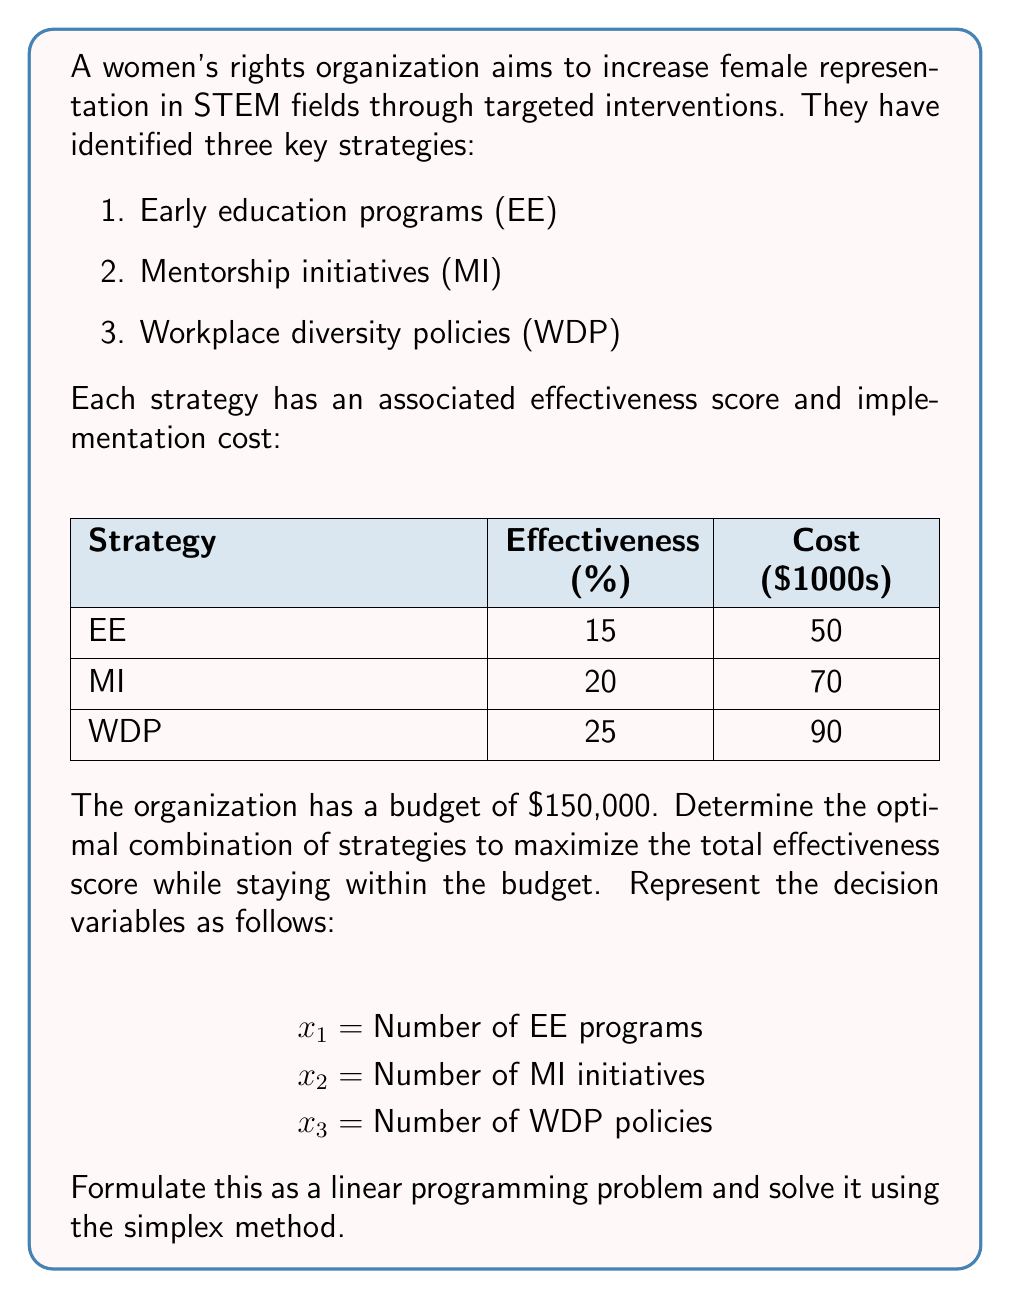Help me with this question. To solve this linear programming problem, we'll follow these steps:

1. Formulate the objective function and constraints
2. Set up the initial simplex tableau
3. Perform iterations until we reach the optimal solution

Step 1: Formulation

Objective function (maximize):
$$Z = 15x_1 + 20x_2 + 25x_3$$

Constraints:
$$50x_1 + 70x_2 + 90x_3 \leq 150$$ (Budget constraint)
$$x_1, x_2, x_3 \geq 0$$ (Non-negativity constraints)

Step 2: Initial Simplex Tableau

Introduce slack variable $s_1$ for the budget constraint:

$$50x_1 + 70x_2 + 90x_3 + s_1 = 150$$

Initial tableau:

| Basic | $x_1$ | $x_2$ | $x_3$ | $s_1$ | RHS |
|-------|-------|-------|-------|-------|-----|
| $s_1$ | 50    | 70    | 90    | 1     | 150 |
| $Z$   | -15   | -20   | -25   | 0     | 0   |

Step 3: Iterations

Iteration 1:
Pivot column: $x_3$ (most negative in $Z$ row)
Pivot row: $s_1$ (only positive ratio)
Pivot element: 90

New tableau:

| Basic | $x_1$ | $x_2$ | $x_3$ | $s_1$ | RHS |
|-------|-------|-------|-------|-------|-----|
| $x_3$ | 5/9   | 7/9   | 1     | 1/90  | 5/3 |
| $Z$   | -2.5  | -2.5  | 0     | 25/90 | 125/3 |

Iteration 2:
Pivot column: $x_1$ or $x_2$ (tie, choose $x_2$)
Pivot row: $x_3$
Pivot element: 7/9

Final tableau:

| Basic | $x_1$ | $x_2$ | $x_3$ | $s_1$ | RHS |
|-------|-------|-------|-------|-------|-----|
| $x_2$ | 5/7   | 1     | 9/7   | 1/70  | 15/7 |
| $Z$   | 0     | 0     | 5/7   | 1/14  | 45   |

The optimal solution is:
$x_1 = 0$, $x_2 = 15/7 \approx 2.14$, $x_3 = 0$, with $Z = 45$

However, since we can't implement fractional programs, we need to round down to the nearest integer:
$x_1 = 0$, $x_2 = 2$, $x_3 = 0$

The actual effectiveness score will be:
$$Z = 15(0) + 20(2) + 25(0) = 40$$

And the budget used will be:
$$50(0) + 70(2) + 90(0) = 140,000$$
Answer: Implement 2 Mentorship Initiatives (MI) for a total effectiveness score of 40. 